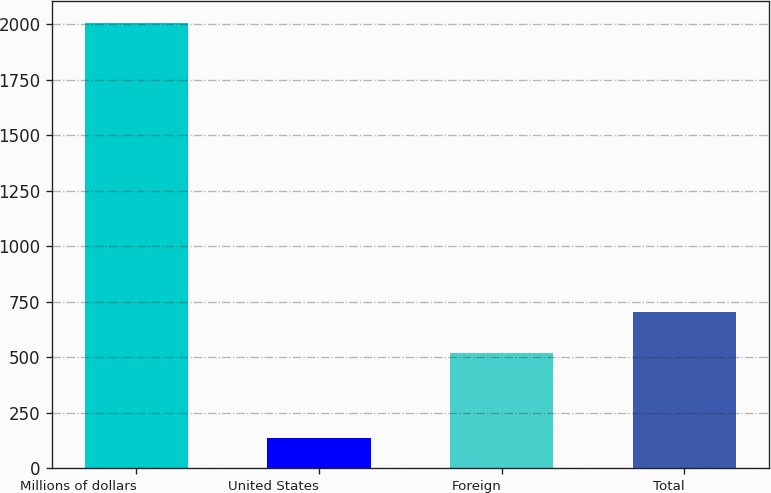<chart> <loc_0><loc_0><loc_500><loc_500><bar_chart><fcel>Millions of dollars<fcel>United States<fcel>Foreign<fcel>Total<nl><fcel>2004<fcel>135<fcel>516<fcel>702.9<nl></chart> 